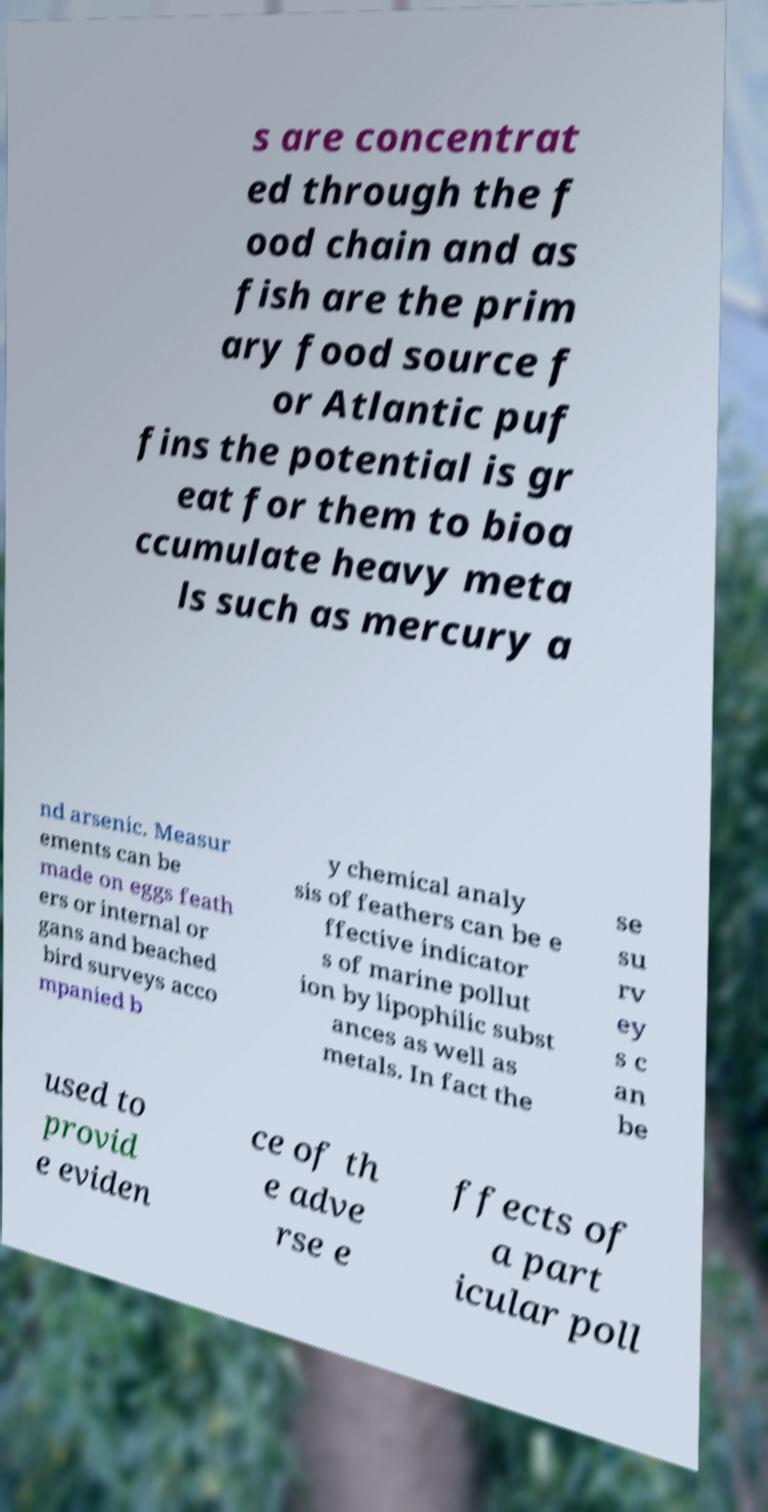Please identify and transcribe the text found in this image. s are concentrat ed through the f ood chain and as fish are the prim ary food source f or Atlantic puf fins the potential is gr eat for them to bioa ccumulate heavy meta ls such as mercury a nd arsenic. Measur ements can be made on eggs feath ers or internal or gans and beached bird surveys acco mpanied b y chemical analy sis of feathers can be e ffective indicator s of marine pollut ion by lipophilic subst ances as well as metals. In fact the se su rv ey s c an be used to provid e eviden ce of th e adve rse e ffects of a part icular poll 